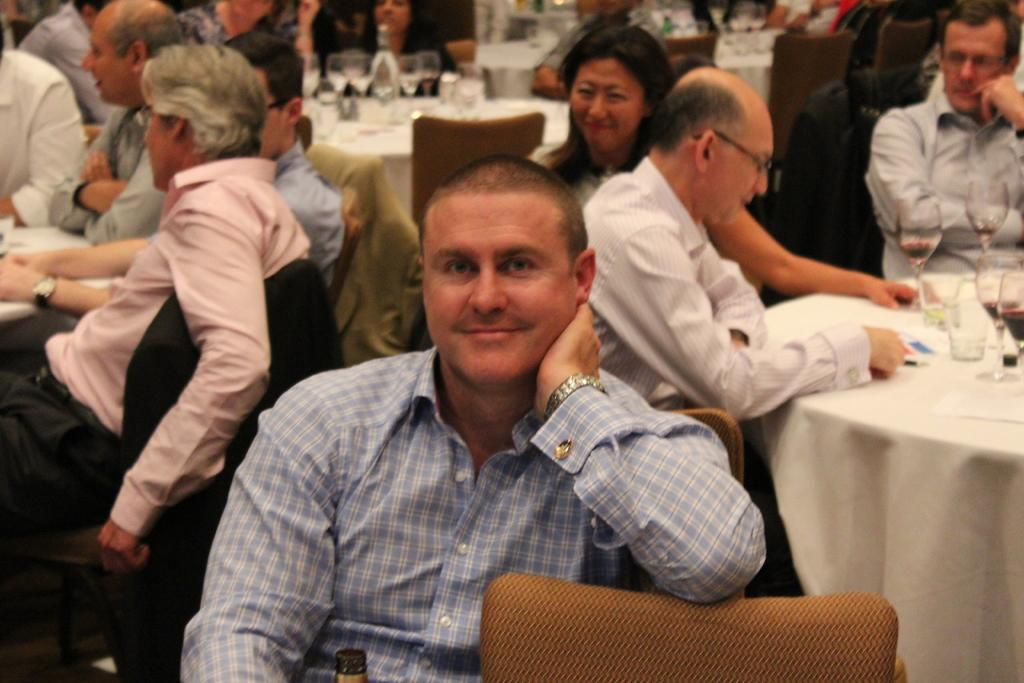What is happening in the image? There is a group of people in the image. What are the people doing in the image? The people are sitting on chairs. Where are the chairs located in relation to each other? The chairs are around a table. What objects can be seen on the table? There are glasses on the table. What is the condition of the people's crush in the image? There is no mention of a crush or any romantic relationship in the image. The image only shows a group of people sitting on chairs around a table. 